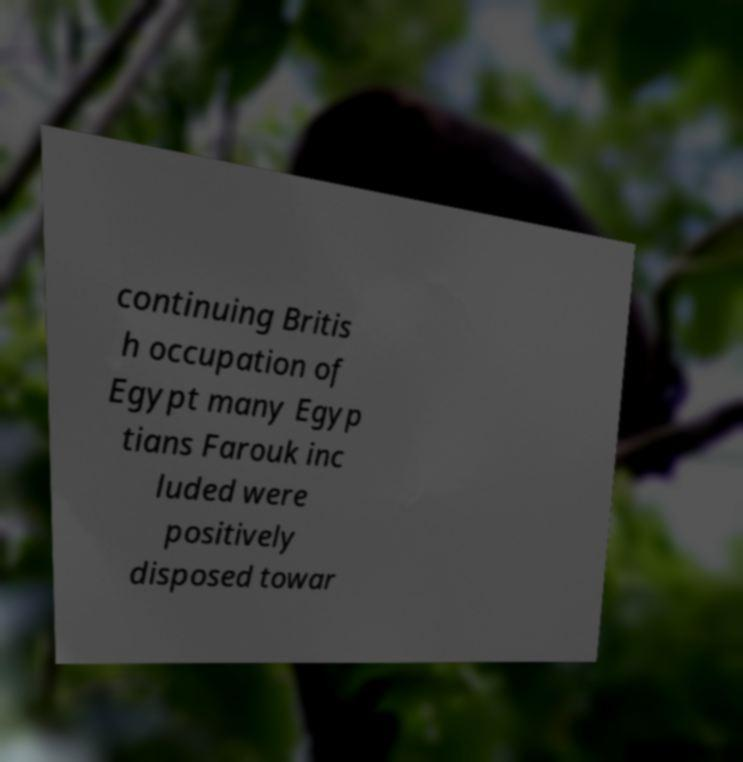Can you accurately transcribe the text from the provided image for me? continuing Britis h occupation of Egypt many Egyp tians Farouk inc luded were positively disposed towar 